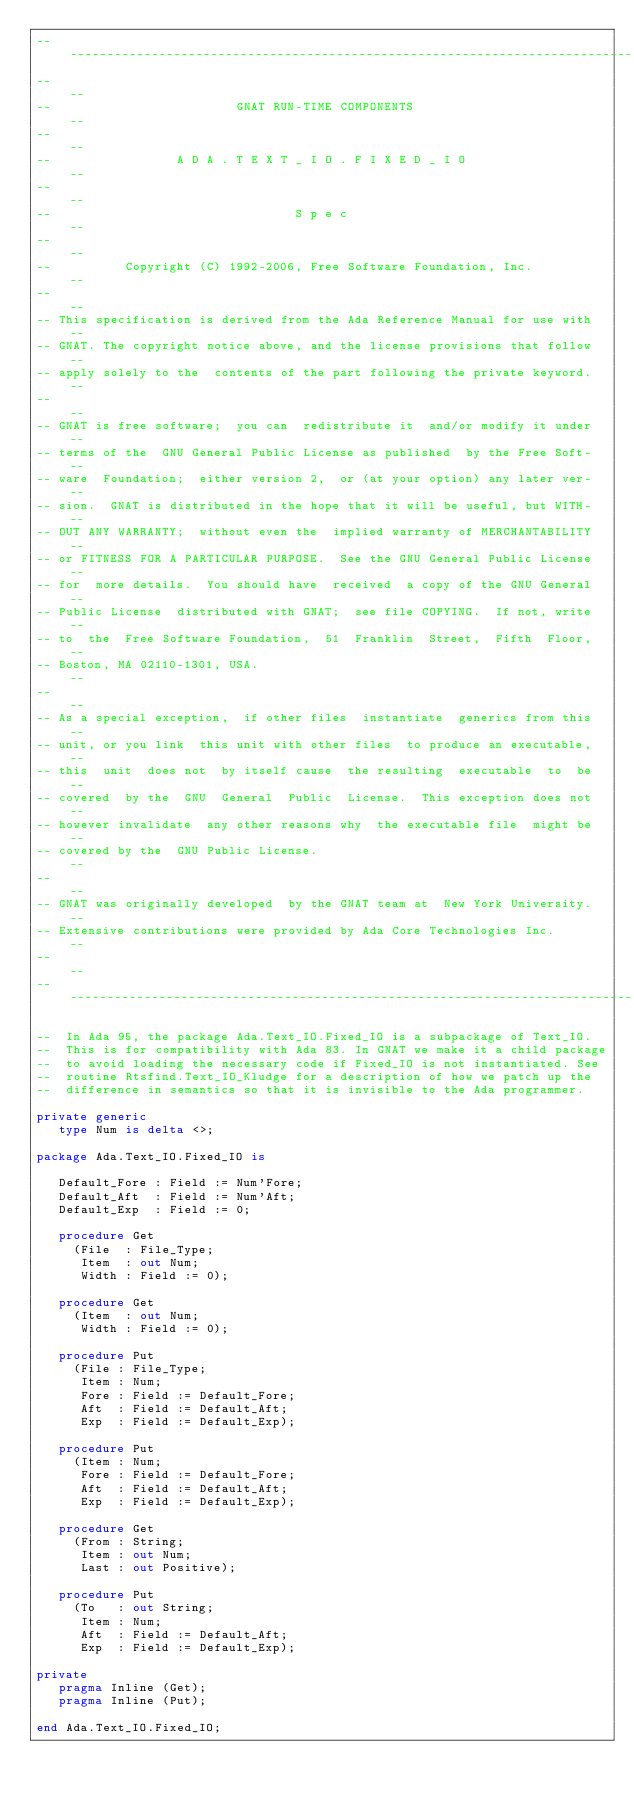<code> <loc_0><loc_0><loc_500><loc_500><_Ada_>------------------------------------------------------------------------------
--                                                                          --
--                         GNAT RUN-TIME COMPONENTS                         --
--                                                                          --
--                 A D A . T E X T _ I O . F I X E D _ I O                  --
--                                                                          --
--                                 S p e c                                  --
--                                                                          --
--          Copyright (C) 1992-2006, Free Software Foundation, Inc.         --
--                                                                          --
-- This specification is derived from the Ada Reference Manual for use with --
-- GNAT. The copyright notice above, and the license provisions that follow --
-- apply solely to the  contents of the part following the private keyword. --
--                                                                          --
-- GNAT is free software;  you can  redistribute it  and/or modify it under --
-- terms of the  GNU General Public License as published  by the Free Soft- --
-- ware  Foundation;  either version 2,  or (at your option) any later ver- --
-- sion.  GNAT is distributed in the hope that it will be useful, but WITH- --
-- OUT ANY WARRANTY;  without even the  implied warranty of MERCHANTABILITY --
-- or FITNESS FOR A PARTICULAR PURPOSE.  See the GNU General Public License --
-- for  more details.  You should have  received  a copy of the GNU General --
-- Public License  distributed with GNAT;  see file COPYING.  If not, write --
-- to  the  Free Software Foundation,  51  Franklin  Street,  Fifth  Floor, --
-- Boston, MA 02110-1301, USA.                                              --
--                                                                          --
-- As a special exception,  if other files  instantiate  generics from this --
-- unit, or you link  this unit with other files  to produce an executable, --
-- this  unit  does not  by itself cause  the resulting  executable  to  be --
-- covered  by the  GNU  General  Public  License.  This exception does not --
-- however invalidate  any other reasons why  the executable file  might be --
-- covered by the  GNU Public License.                                      --
--                                                                          --
-- GNAT was originally developed  by the GNAT team at  New York University. --
-- Extensive contributions were provided by Ada Core Technologies Inc.      --
--                                                                          --
------------------------------------------------------------------------------

--  In Ada 95, the package Ada.Text_IO.Fixed_IO is a subpackage of Text_IO.
--  This is for compatibility with Ada 83. In GNAT we make it a child package
--  to avoid loading the necessary code if Fixed_IO is not instantiated. See
--  routine Rtsfind.Text_IO_Kludge for a description of how we patch up the
--  difference in semantics so that it is invisible to the Ada programmer.

private generic
   type Num is delta <>;

package Ada.Text_IO.Fixed_IO is

   Default_Fore : Field := Num'Fore;
   Default_Aft  : Field := Num'Aft;
   Default_Exp  : Field := 0;

   procedure Get
     (File  : File_Type;
      Item  : out Num;
      Width : Field := 0);

   procedure Get
     (Item  : out Num;
      Width : Field := 0);

   procedure Put
     (File : File_Type;
      Item : Num;
      Fore : Field := Default_Fore;
      Aft  : Field := Default_Aft;
      Exp  : Field := Default_Exp);

   procedure Put
     (Item : Num;
      Fore : Field := Default_Fore;
      Aft  : Field := Default_Aft;
      Exp  : Field := Default_Exp);

   procedure Get
     (From : String;
      Item : out Num;
      Last : out Positive);

   procedure Put
     (To   : out String;
      Item : Num;
      Aft  : Field := Default_Aft;
      Exp  : Field := Default_Exp);

private
   pragma Inline (Get);
   pragma Inline (Put);

end Ada.Text_IO.Fixed_IO;
</code> 